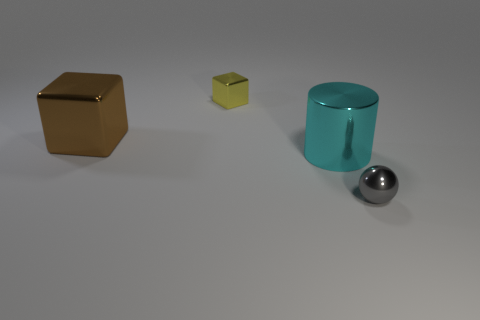Add 3 big cyan metal cylinders. How many objects exist? 7 Subtract all cylinders. How many objects are left? 3 Add 2 cyan cylinders. How many cyan cylinders exist? 3 Subtract 0 purple blocks. How many objects are left? 4 Subtract all large red balls. Subtract all large cyan cylinders. How many objects are left? 3 Add 4 big cyan metallic objects. How many big cyan metallic objects are left? 5 